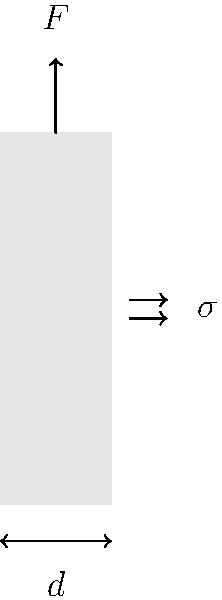As a health-conscious individual interested in sustainable living, you're designing a reusable water bottle for your daily jogs. The bottle has a cylindrical shape with diameter $d$ and is subjected to an axial force $F$ at the top. If the wall thickness of the bottle is negligible compared to its diameter, what is the expression for the axial stress $\sigma$ in the bottle wall? To find the axial stress in the water bottle wall, we'll follow these steps:

1. Recall the formula for axial stress: $\sigma = \frac{F}{A}$, where $F$ is the applied force and $A$ is the cross-sectional area.

2. For a thin-walled cylinder, the cross-sectional area can be approximated as the circumference of the circle multiplied by the wall thickness. However, since the wall thickness is negligible, we'll use the mean diameter $d$.

3. The circumference of a circle is given by $\pi d$.

4. Therefore, the cross-sectional area $A$ can be expressed as $A = \pi d t$, where $t$ is the wall thickness.

5. Substituting this into the stress formula:

   $\sigma = \frac{F}{\pi d t}$

6. Since the wall thickness $t$ is negligible compared to the diameter, we can consider it as a constant in this expression.

This formula gives us the axial stress in the bottle wall, which is important for ensuring the durability and safety of your reusable water bottle during your jogging sessions.
Answer: $\sigma = \frac{F}{\pi d t}$ 